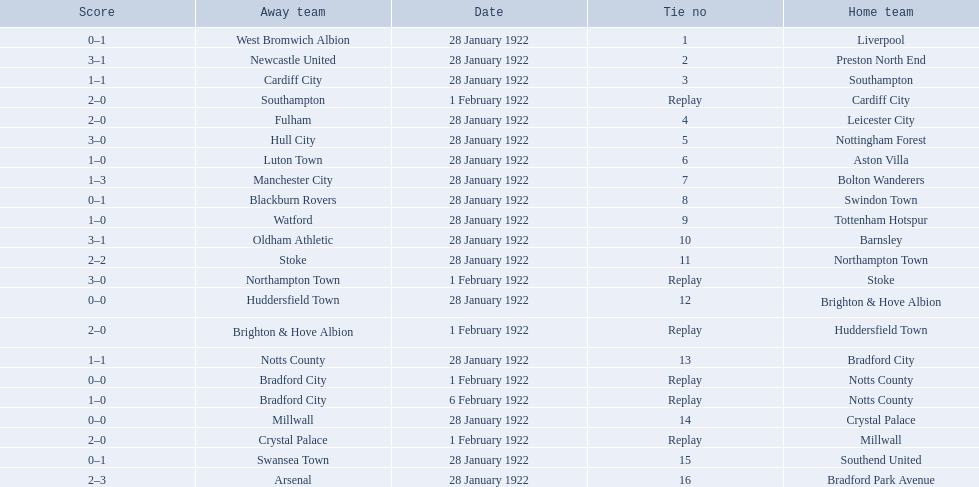What are all of the home teams? Liverpool, Preston North End, Southampton, Cardiff City, Leicester City, Nottingham Forest, Aston Villa, Bolton Wanderers, Swindon Town, Tottenham Hotspur, Barnsley, Northampton Town, Stoke, Brighton & Hove Albion, Huddersfield Town, Bradford City, Notts County, Notts County, Crystal Palace, Millwall, Southend United, Bradford Park Avenue. What were the scores? 0–1, 3–1, 1–1, 2–0, 2–0, 3–0, 1–0, 1–3, 0–1, 1–0, 3–1, 2–2, 3–0, 0–0, 2–0, 1–1, 0–0, 1–0, 0–0, 2–0, 0–1, 2–3. On which dates did they play? 28 January 1922, 28 January 1922, 28 January 1922, 1 February 1922, 28 January 1922, 28 January 1922, 28 January 1922, 28 January 1922, 28 January 1922, 28 January 1922, 28 January 1922, 28 January 1922, 1 February 1922, 28 January 1922, 1 February 1922, 28 January 1922, 1 February 1922, 6 February 1922, 28 January 1922, 1 February 1922, 28 January 1922, 28 January 1922. Which teams played on 28 january 1922? Liverpool, Preston North End, Southampton, Leicester City, Nottingham Forest, Aston Villa, Bolton Wanderers, Swindon Town, Tottenham Hotspur, Barnsley, Northampton Town, Brighton & Hove Albion, Bradford City, Crystal Palace, Southend United, Bradford Park Avenue. Of those, which scored the same as aston villa? Tottenham Hotspur. 